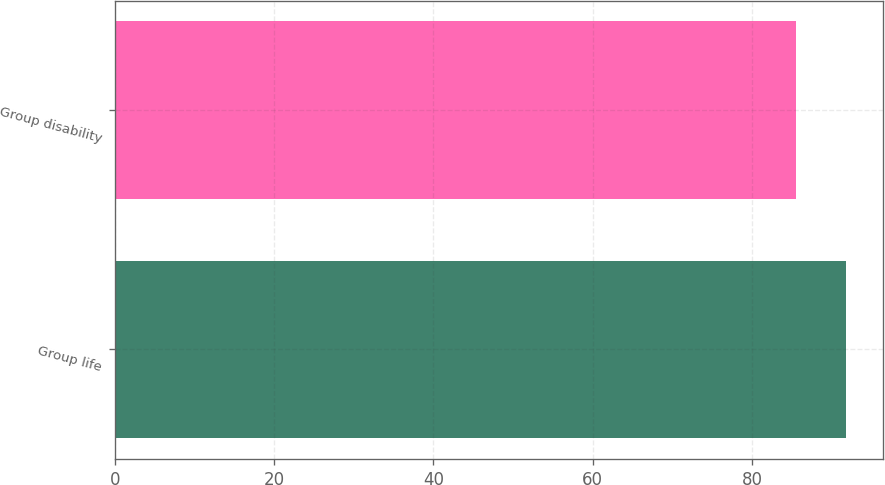Convert chart to OTSL. <chart><loc_0><loc_0><loc_500><loc_500><bar_chart><fcel>Group life<fcel>Group disability<nl><fcel>91.8<fcel>85.5<nl></chart> 